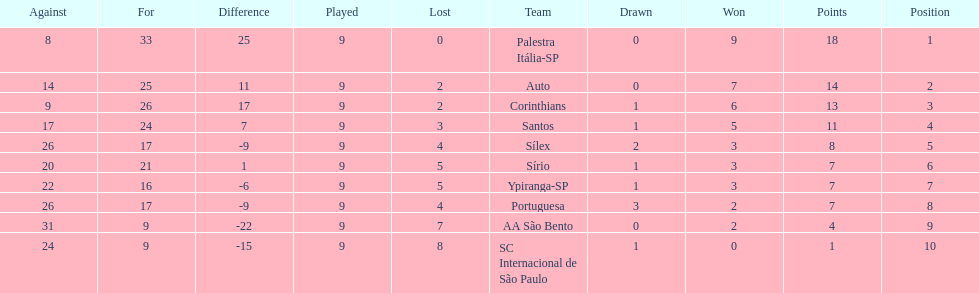In 1926 brazilian football,what was the total number of points scored? 90. 